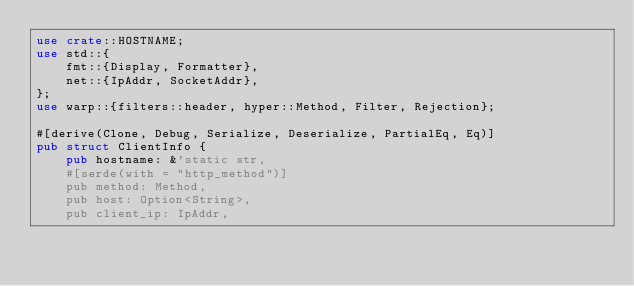Convert code to text. <code><loc_0><loc_0><loc_500><loc_500><_Rust_>use crate::HOSTNAME;
use std::{
    fmt::{Display, Formatter},
    net::{IpAddr, SocketAddr},
};
use warp::{filters::header, hyper::Method, Filter, Rejection};

#[derive(Clone, Debug, Serialize, Deserialize, PartialEq, Eq)]
pub struct ClientInfo {
    pub hostname: &'static str,
    #[serde(with = "http_method")]
    pub method: Method,
    pub host: Option<String>,
    pub client_ip: IpAddr,</code> 